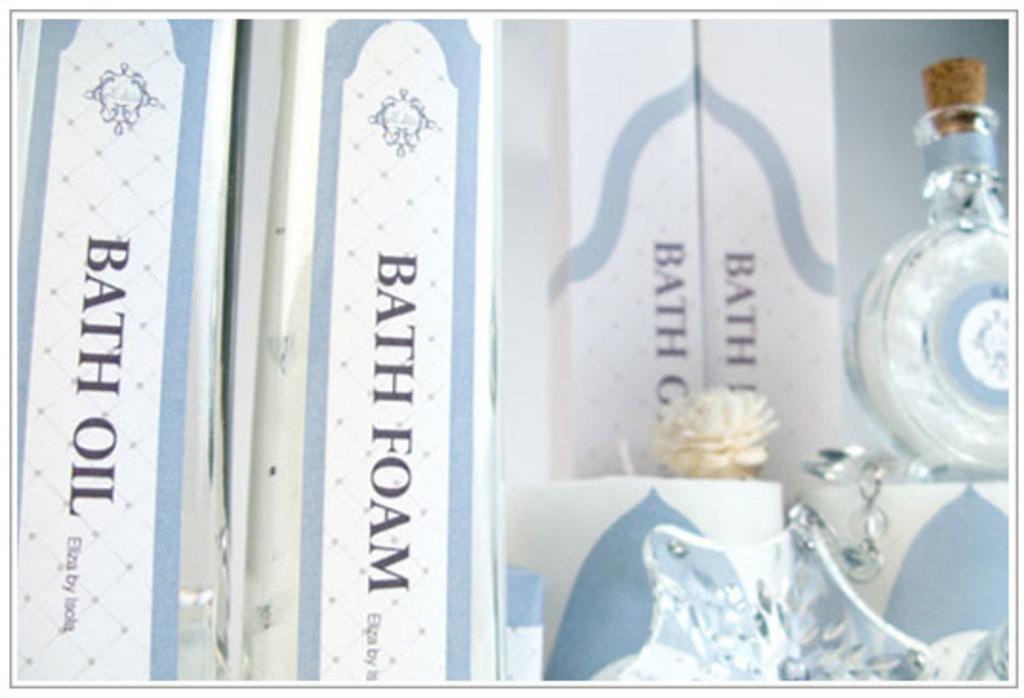What kind of oil is shown?
Your answer should be compact. Bath. 